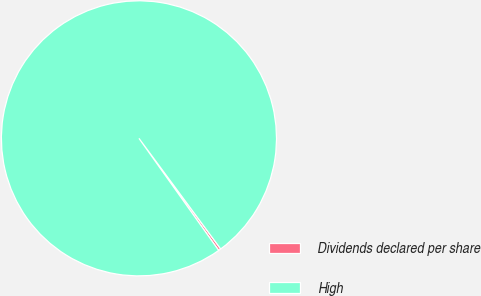<chart> <loc_0><loc_0><loc_500><loc_500><pie_chart><fcel>Dividends declared per share<fcel>High<nl><fcel>0.29%<fcel>99.71%<nl></chart> 